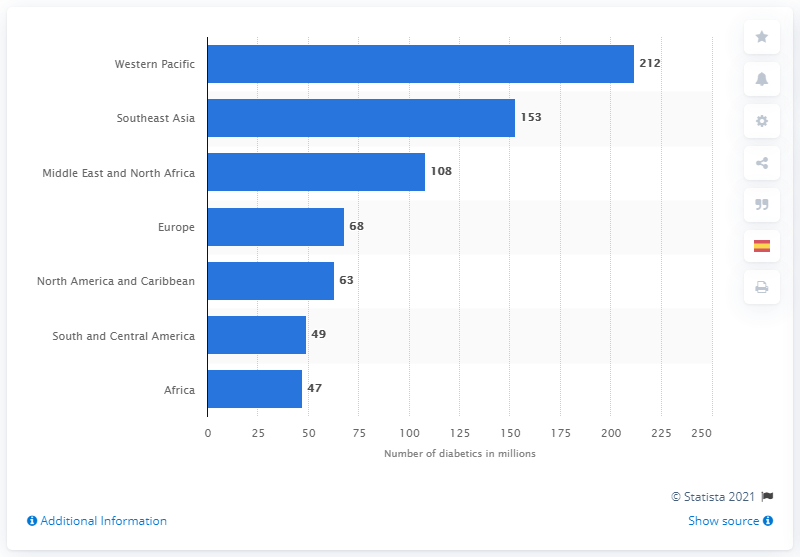Give some essential details in this illustration. It is projected that by 2045, the population of diabetic individuals in the Western Pacific region will reach 212 million. It is estimated that by 2045, the population of diabetic individuals in the Western Pacific region will reach 212 million. 